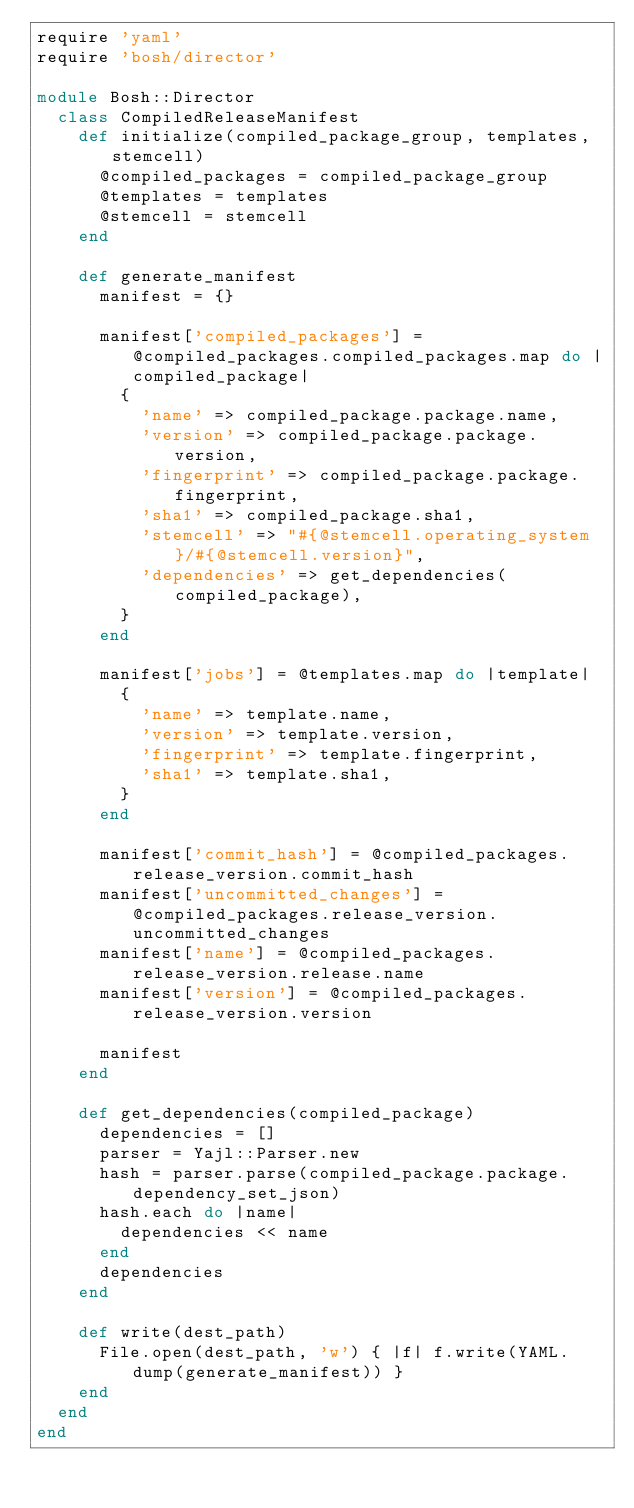Convert code to text. <code><loc_0><loc_0><loc_500><loc_500><_Ruby_>require 'yaml'
require 'bosh/director'

module Bosh::Director
  class CompiledReleaseManifest
    def initialize(compiled_package_group, templates, stemcell)
      @compiled_packages = compiled_package_group
      @templates = templates
      @stemcell = stemcell
    end

    def generate_manifest
      manifest = {}

      manifest['compiled_packages'] = @compiled_packages.compiled_packages.map do |compiled_package|
        {
          'name' => compiled_package.package.name,
          'version' => compiled_package.package.version,
          'fingerprint' => compiled_package.package.fingerprint,
          'sha1' => compiled_package.sha1,
          'stemcell' => "#{@stemcell.operating_system}/#{@stemcell.version}",
          'dependencies' => get_dependencies(compiled_package),
        }
      end

      manifest['jobs'] = @templates.map do |template|
        {
          'name' => template.name,
          'version' => template.version,
          'fingerprint' => template.fingerprint,
          'sha1' => template.sha1,
        }
      end

      manifest['commit_hash'] = @compiled_packages.release_version.commit_hash
      manifest['uncommitted_changes'] = @compiled_packages.release_version.uncommitted_changes
      manifest['name'] = @compiled_packages.release_version.release.name
      manifest['version'] = @compiled_packages.release_version.version

      manifest
    end

    def get_dependencies(compiled_package)
      dependencies = []
      parser = Yajl::Parser.new
      hash = parser.parse(compiled_package.package.dependency_set_json)
      hash.each do |name|
        dependencies << name
      end
      dependencies
    end

    def write(dest_path)
      File.open(dest_path, 'w') { |f| f.write(YAML.dump(generate_manifest)) }
    end
  end
end
</code> 